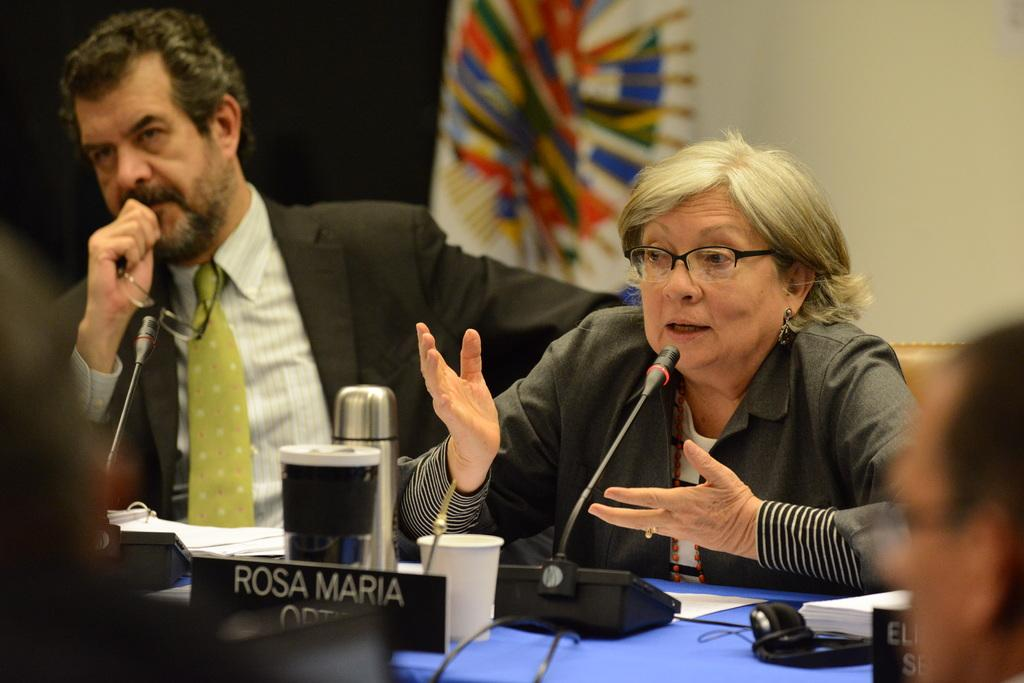How many people are present in the image? There are two people in the image. What are the people doing in the image? The people are sitting in front of a table. What objects can be seen on the table? There is a screen, a bottle, a cup, and a mic on the table. Is there any signage or identification in the image? Yes, there is a name board in the image. How many shoes are visible on the table in the image? There are no shoes visible on the table in the image. What type of giants can be seen in the image? There are no giants present in the image. 